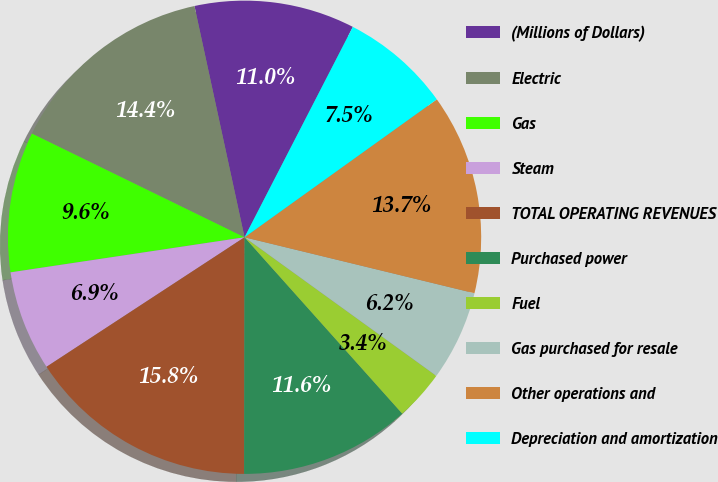Convert chart to OTSL. <chart><loc_0><loc_0><loc_500><loc_500><pie_chart><fcel>(Millions of Dollars)<fcel>Electric<fcel>Gas<fcel>Steam<fcel>TOTAL OPERATING REVENUES<fcel>Purchased power<fcel>Fuel<fcel>Gas purchased for resale<fcel>Other operations and<fcel>Depreciation and amortization<nl><fcel>10.96%<fcel>14.38%<fcel>9.59%<fcel>6.85%<fcel>15.75%<fcel>11.64%<fcel>3.43%<fcel>6.16%<fcel>13.7%<fcel>7.53%<nl></chart> 